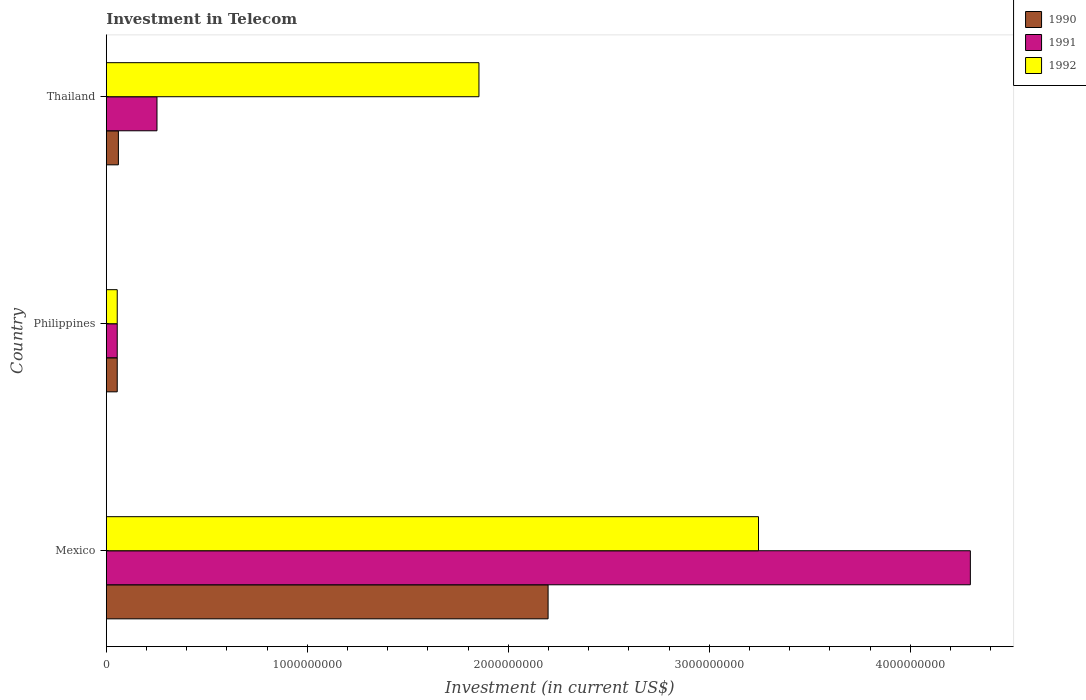How many groups of bars are there?
Make the answer very short. 3. Are the number of bars per tick equal to the number of legend labels?
Your answer should be compact. Yes. How many bars are there on the 1st tick from the bottom?
Ensure brevity in your answer.  3. What is the label of the 2nd group of bars from the top?
Give a very brief answer. Philippines. What is the amount invested in telecom in 1992 in Thailand?
Give a very brief answer. 1.85e+09. Across all countries, what is the maximum amount invested in telecom in 1990?
Offer a terse response. 2.20e+09. Across all countries, what is the minimum amount invested in telecom in 1992?
Offer a terse response. 5.42e+07. In which country was the amount invested in telecom in 1991 minimum?
Your answer should be compact. Philippines. What is the total amount invested in telecom in 1991 in the graph?
Your answer should be compact. 4.61e+09. What is the difference between the amount invested in telecom in 1992 in Philippines and that in Thailand?
Ensure brevity in your answer.  -1.80e+09. What is the difference between the amount invested in telecom in 1991 in Philippines and the amount invested in telecom in 1990 in Mexico?
Offer a very short reply. -2.14e+09. What is the average amount invested in telecom in 1992 per country?
Ensure brevity in your answer.  1.72e+09. What is the difference between the amount invested in telecom in 1992 and amount invested in telecom in 1991 in Mexico?
Offer a very short reply. -1.05e+09. In how many countries, is the amount invested in telecom in 1991 greater than 2200000000 US$?
Make the answer very short. 1. What is the ratio of the amount invested in telecom in 1991 in Mexico to that in Philippines?
Your answer should be compact. 79.32. What is the difference between the highest and the second highest amount invested in telecom in 1992?
Keep it short and to the point. 1.39e+09. What is the difference between the highest and the lowest amount invested in telecom in 1992?
Provide a short and direct response. 3.19e+09. In how many countries, is the amount invested in telecom in 1992 greater than the average amount invested in telecom in 1992 taken over all countries?
Keep it short and to the point. 2. How many countries are there in the graph?
Make the answer very short. 3. Are the values on the major ticks of X-axis written in scientific E-notation?
Give a very brief answer. No. Does the graph contain any zero values?
Ensure brevity in your answer.  No. Where does the legend appear in the graph?
Your answer should be compact. Top right. How many legend labels are there?
Provide a succinct answer. 3. How are the legend labels stacked?
Your answer should be very brief. Vertical. What is the title of the graph?
Provide a succinct answer. Investment in Telecom. Does "1976" appear as one of the legend labels in the graph?
Ensure brevity in your answer.  No. What is the label or title of the X-axis?
Provide a succinct answer. Investment (in current US$). What is the label or title of the Y-axis?
Your response must be concise. Country. What is the Investment (in current US$) of 1990 in Mexico?
Ensure brevity in your answer.  2.20e+09. What is the Investment (in current US$) of 1991 in Mexico?
Your answer should be very brief. 4.30e+09. What is the Investment (in current US$) of 1992 in Mexico?
Ensure brevity in your answer.  3.24e+09. What is the Investment (in current US$) of 1990 in Philippines?
Provide a succinct answer. 5.42e+07. What is the Investment (in current US$) of 1991 in Philippines?
Give a very brief answer. 5.42e+07. What is the Investment (in current US$) of 1992 in Philippines?
Your answer should be very brief. 5.42e+07. What is the Investment (in current US$) of 1990 in Thailand?
Provide a short and direct response. 6.00e+07. What is the Investment (in current US$) in 1991 in Thailand?
Your response must be concise. 2.52e+08. What is the Investment (in current US$) of 1992 in Thailand?
Your answer should be very brief. 1.85e+09. Across all countries, what is the maximum Investment (in current US$) in 1990?
Keep it short and to the point. 2.20e+09. Across all countries, what is the maximum Investment (in current US$) in 1991?
Provide a short and direct response. 4.30e+09. Across all countries, what is the maximum Investment (in current US$) of 1992?
Keep it short and to the point. 3.24e+09. Across all countries, what is the minimum Investment (in current US$) in 1990?
Offer a terse response. 5.42e+07. Across all countries, what is the minimum Investment (in current US$) in 1991?
Give a very brief answer. 5.42e+07. Across all countries, what is the minimum Investment (in current US$) in 1992?
Ensure brevity in your answer.  5.42e+07. What is the total Investment (in current US$) in 1990 in the graph?
Provide a succinct answer. 2.31e+09. What is the total Investment (in current US$) of 1991 in the graph?
Offer a very short reply. 4.61e+09. What is the total Investment (in current US$) of 1992 in the graph?
Make the answer very short. 5.15e+09. What is the difference between the Investment (in current US$) of 1990 in Mexico and that in Philippines?
Offer a very short reply. 2.14e+09. What is the difference between the Investment (in current US$) in 1991 in Mexico and that in Philippines?
Provide a succinct answer. 4.24e+09. What is the difference between the Investment (in current US$) in 1992 in Mexico and that in Philippines?
Keep it short and to the point. 3.19e+09. What is the difference between the Investment (in current US$) of 1990 in Mexico and that in Thailand?
Give a very brief answer. 2.14e+09. What is the difference between the Investment (in current US$) in 1991 in Mexico and that in Thailand?
Make the answer very short. 4.05e+09. What is the difference between the Investment (in current US$) in 1992 in Mexico and that in Thailand?
Offer a terse response. 1.39e+09. What is the difference between the Investment (in current US$) in 1990 in Philippines and that in Thailand?
Provide a succinct answer. -5.80e+06. What is the difference between the Investment (in current US$) of 1991 in Philippines and that in Thailand?
Offer a terse response. -1.98e+08. What is the difference between the Investment (in current US$) in 1992 in Philippines and that in Thailand?
Provide a short and direct response. -1.80e+09. What is the difference between the Investment (in current US$) in 1990 in Mexico and the Investment (in current US$) in 1991 in Philippines?
Ensure brevity in your answer.  2.14e+09. What is the difference between the Investment (in current US$) in 1990 in Mexico and the Investment (in current US$) in 1992 in Philippines?
Your answer should be very brief. 2.14e+09. What is the difference between the Investment (in current US$) in 1991 in Mexico and the Investment (in current US$) in 1992 in Philippines?
Your answer should be very brief. 4.24e+09. What is the difference between the Investment (in current US$) of 1990 in Mexico and the Investment (in current US$) of 1991 in Thailand?
Your answer should be compact. 1.95e+09. What is the difference between the Investment (in current US$) of 1990 in Mexico and the Investment (in current US$) of 1992 in Thailand?
Provide a succinct answer. 3.44e+08. What is the difference between the Investment (in current US$) in 1991 in Mexico and the Investment (in current US$) in 1992 in Thailand?
Make the answer very short. 2.44e+09. What is the difference between the Investment (in current US$) of 1990 in Philippines and the Investment (in current US$) of 1991 in Thailand?
Ensure brevity in your answer.  -1.98e+08. What is the difference between the Investment (in current US$) in 1990 in Philippines and the Investment (in current US$) in 1992 in Thailand?
Ensure brevity in your answer.  -1.80e+09. What is the difference between the Investment (in current US$) in 1991 in Philippines and the Investment (in current US$) in 1992 in Thailand?
Ensure brevity in your answer.  -1.80e+09. What is the average Investment (in current US$) in 1990 per country?
Provide a short and direct response. 7.71e+08. What is the average Investment (in current US$) in 1991 per country?
Your answer should be very brief. 1.54e+09. What is the average Investment (in current US$) in 1992 per country?
Give a very brief answer. 1.72e+09. What is the difference between the Investment (in current US$) in 1990 and Investment (in current US$) in 1991 in Mexico?
Provide a short and direct response. -2.10e+09. What is the difference between the Investment (in current US$) in 1990 and Investment (in current US$) in 1992 in Mexico?
Provide a short and direct response. -1.05e+09. What is the difference between the Investment (in current US$) in 1991 and Investment (in current US$) in 1992 in Mexico?
Offer a very short reply. 1.05e+09. What is the difference between the Investment (in current US$) in 1990 and Investment (in current US$) in 1991 in Thailand?
Make the answer very short. -1.92e+08. What is the difference between the Investment (in current US$) of 1990 and Investment (in current US$) of 1992 in Thailand?
Make the answer very short. -1.79e+09. What is the difference between the Investment (in current US$) of 1991 and Investment (in current US$) of 1992 in Thailand?
Your answer should be very brief. -1.60e+09. What is the ratio of the Investment (in current US$) of 1990 in Mexico to that in Philippines?
Your answer should be compact. 40.55. What is the ratio of the Investment (in current US$) in 1991 in Mexico to that in Philippines?
Offer a terse response. 79.32. What is the ratio of the Investment (in current US$) of 1992 in Mexico to that in Philippines?
Offer a very short reply. 59.87. What is the ratio of the Investment (in current US$) of 1990 in Mexico to that in Thailand?
Your answer should be compact. 36.63. What is the ratio of the Investment (in current US$) in 1991 in Mexico to that in Thailand?
Provide a succinct answer. 17.06. What is the ratio of the Investment (in current US$) in 1992 in Mexico to that in Thailand?
Give a very brief answer. 1.75. What is the ratio of the Investment (in current US$) of 1990 in Philippines to that in Thailand?
Your answer should be very brief. 0.9. What is the ratio of the Investment (in current US$) of 1991 in Philippines to that in Thailand?
Provide a succinct answer. 0.22. What is the ratio of the Investment (in current US$) in 1992 in Philippines to that in Thailand?
Your response must be concise. 0.03. What is the difference between the highest and the second highest Investment (in current US$) of 1990?
Provide a short and direct response. 2.14e+09. What is the difference between the highest and the second highest Investment (in current US$) of 1991?
Keep it short and to the point. 4.05e+09. What is the difference between the highest and the second highest Investment (in current US$) of 1992?
Make the answer very short. 1.39e+09. What is the difference between the highest and the lowest Investment (in current US$) of 1990?
Provide a succinct answer. 2.14e+09. What is the difference between the highest and the lowest Investment (in current US$) of 1991?
Provide a short and direct response. 4.24e+09. What is the difference between the highest and the lowest Investment (in current US$) in 1992?
Your answer should be very brief. 3.19e+09. 